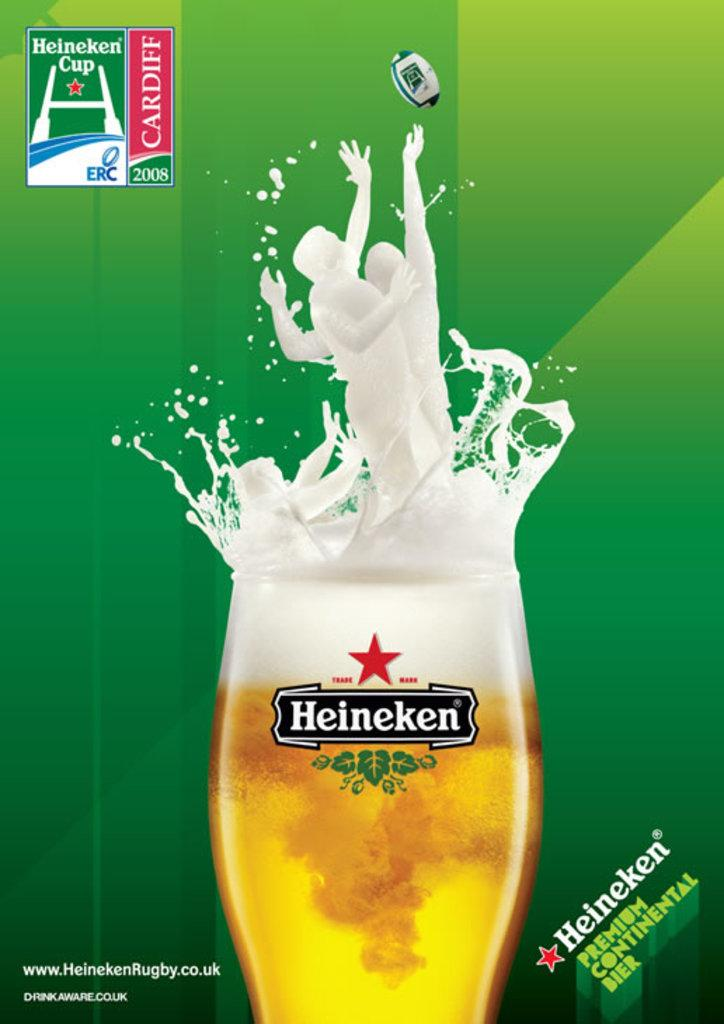Provide a one-sentence caption for the provided image. An add for the Heineken Cup has a glass of Heineken that has players splashing out of it. 